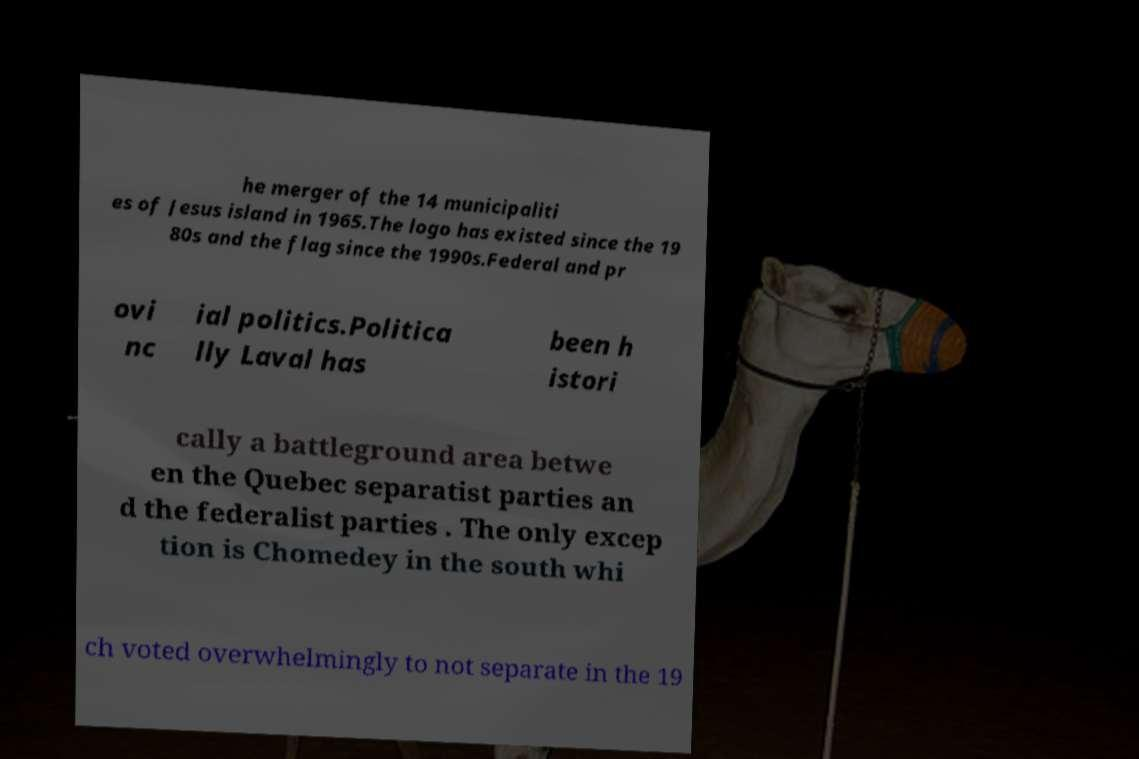There's text embedded in this image that I need extracted. Can you transcribe it verbatim? he merger of the 14 municipaliti es of Jesus island in 1965.The logo has existed since the 19 80s and the flag since the 1990s.Federal and pr ovi nc ial politics.Politica lly Laval has been h istori cally a battleground area betwe en the Quebec separatist parties an d the federalist parties . The only excep tion is Chomedey in the south whi ch voted overwhelmingly to not separate in the 19 